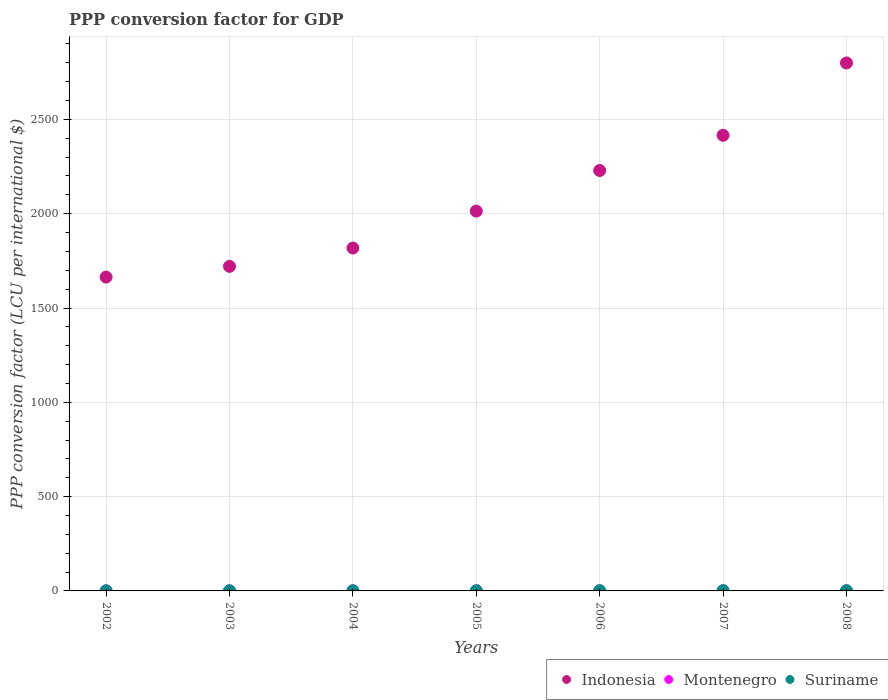Is the number of dotlines equal to the number of legend labels?
Your answer should be compact. Yes. What is the PPP conversion factor for GDP in Indonesia in 2002?
Your answer should be compact. 1663.89. Across all years, what is the maximum PPP conversion factor for GDP in Suriname?
Provide a short and direct response. 1.45. Across all years, what is the minimum PPP conversion factor for GDP in Suriname?
Give a very brief answer. 0.61. In which year was the PPP conversion factor for GDP in Indonesia minimum?
Give a very brief answer. 2002. What is the total PPP conversion factor for GDP in Montenegro in the graph?
Give a very brief answer. 2.39. What is the difference between the PPP conversion factor for GDP in Suriname in 2006 and that in 2008?
Your response must be concise. -0.22. What is the difference between the PPP conversion factor for GDP in Montenegro in 2004 and the PPP conversion factor for GDP in Suriname in 2005?
Keep it short and to the point. -0.55. What is the average PPP conversion factor for GDP in Indonesia per year?
Offer a terse response. 2094.35. In the year 2004, what is the difference between the PPP conversion factor for GDP in Montenegro and PPP conversion factor for GDP in Suriname?
Offer a very short reply. -0.46. In how many years, is the PPP conversion factor for GDP in Suriname greater than 1600 LCU?
Your answer should be compact. 0. What is the ratio of the PPP conversion factor for GDP in Suriname in 2005 to that in 2008?
Provide a short and direct response. 0.62. Is the PPP conversion factor for GDP in Indonesia in 2005 less than that in 2006?
Your response must be concise. Yes. What is the difference between the highest and the second highest PPP conversion factor for GDP in Montenegro?
Ensure brevity in your answer.  0.01. What is the difference between the highest and the lowest PPP conversion factor for GDP in Indonesia?
Offer a very short reply. 1135.31. Is the sum of the PPP conversion factor for GDP in Suriname in 2006 and 2007 greater than the maximum PPP conversion factor for GDP in Montenegro across all years?
Give a very brief answer. Yes. Is it the case that in every year, the sum of the PPP conversion factor for GDP in Suriname and PPP conversion factor for GDP in Montenegro  is greater than the PPP conversion factor for GDP in Indonesia?
Your answer should be compact. No. Does the PPP conversion factor for GDP in Suriname monotonically increase over the years?
Provide a short and direct response. Yes. Is the PPP conversion factor for GDP in Suriname strictly greater than the PPP conversion factor for GDP in Montenegro over the years?
Give a very brief answer. Yes. What is the difference between two consecutive major ticks on the Y-axis?
Ensure brevity in your answer.  500. Are the values on the major ticks of Y-axis written in scientific E-notation?
Provide a succinct answer. No. Does the graph contain any zero values?
Make the answer very short. No. Does the graph contain grids?
Keep it short and to the point. Yes. Where does the legend appear in the graph?
Offer a terse response. Bottom right. What is the title of the graph?
Offer a very short reply. PPP conversion factor for GDP. Does "Tuvalu" appear as one of the legend labels in the graph?
Offer a terse response. No. What is the label or title of the Y-axis?
Ensure brevity in your answer.  PPP conversion factor (LCU per international $). What is the PPP conversion factor (LCU per international $) of Indonesia in 2002?
Offer a terse response. 1663.89. What is the PPP conversion factor (LCU per international $) in Montenegro in 2002?
Your answer should be compact. 0.32. What is the PPP conversion factor (LCU per international $) of Suriname in 2002?
Keep it short and to the point. 0.61. What is the PPP conversion factor (LCU per international $) in Indonesia in 2003?
Give a very brief answer. 1720.88. What is the PPP conversion factor (LCU per international $) in Montenegro in 2003?
Give a very brief answer. 0.34. What is the PPP conversion factor (LCU per international $) in Suriname in 2003?
Give a very brief answer. 0.74. What is the PPP conversion factor (LCU per international $) in Indonesia in 2004?
Ensure brevity in your answer.  1818.04. What is the PPP conversion factor (LCU per international $) of Montenegro in 2004?
Make the answer very short. 0.35. What is the PPP conversion factor (LCU per international $) of Suriname in 2004?
Provide a succinct answer. 0.81. What is the PPP conversion factor (LCU per international $) of Indonesia in 2005?
Offer a very short reply. 2013.8. What is the PPP conversion factor (LCU per international $) of Montenegro in 2005?
Provide a succinct answer. 0.35. What is the PPP conversion factor (LCU per international $) in Suriname in 2005?
Ensure brevity in your answer.  0.9. What is the PPP conversion factor (LCU per international $) of Indonesia in 2006?
Offer a terse response. 2229.01. What is the PPP conversion factor (LCU per international $) of Montenegro in 2006?
Offer a terse response. 0.33. What is the PPP conversion factor (LCU per international $) of Suriname in 2006?
Provide a short and direct response. 1.24. What is the PPP conversion factor (LCU per international $) in Indonesia in 2007?
Ensure brevity in your answer.  2415.67. What is the PPP conversion factor (LCU per international $) in Montenegro in 2007?
Your answer should be very brief. 0.35. What is the PPP conversion factor (LCU per international $) in Suriname in 2007?
Provide a short and direct response. 1.28. What is the PPP conversion factor (LCU per international $) of Indonesia in 2008?
Offer a terse response. 2799.2. What is the PPP conversion factor (LCU per international $) of Montenegro in 2008?
Offer a terse response. 0.36. What is the PPP conversion factor (LCU per international $) of Suriname in 2008?
Keep it short and to the point. 1.45. Across all years, what is the maximum PPP conversion factor (LCU per international $) in Indonesia?
Your answer should be very brief. 2799.2. Across all years, what is the maximum PPP conversion factor (LCU per international $) of Montenegro?
Your response must be concise. 0.36. Across all years, what is the maximum PPP conversion factor (LCU per international $) of Suriname?
Your response must be concise. 1.45. Across all years, what is the minimum PPP conversion factor (LCU per international $) of Indonesia?
Your answer should be compact. 1663.89. Across all years, what is the minimum PPP conversion factor (LCU per international $) in Montenegro?
Offer a very short reply. 0.32. Across all years, what is the minimum PPP conversion factor (LCU per international $) in Suriname?
Provide a short and direct response. 0.61. What is the total PPP conversion factor (LCU per international $) of Indonesia in the graph?
Provide a short and direct response. 1.47e+04. What is the total PPP conversion factor (LCU per international $) in Montenegro in the graph?
Provide a short and direct response. 2.39. What is the total PPP conversion factor (LCU per international $) of Suriname in the graph?
Keep it short and to the point. 7.03. What is the difference between the PPP conversion factor (LCU per international $) in Indonesia in 2002 and that in 2003?
Offer a very short reply. -56.99. What is the difference between the PPP conversion factor (LCU per international $) in Montenegro in 2002 and that in 2003?
Provide a succinct answer. -0.02. What is the difference between the PPP conversion factor (LCU per international $) of Suriname in 2002 and that in 2003?
Offer a terse response. -0.13. What is the difference between the PPP conversion factor (LCU per international $) in Indonesia in 2002 and that in 2004?
Ensure brevity in your answer.  -154.15. What is the difference between the PPP conversion factor (LCU per international $) in Montenegro in 2002 and that in 2004?
Offer a very short reply. -0.03. What is the difference between the PPP conversion factor (LCU per international $) in Suriname in 2002 and that in 2004?
Your answer should be compact. -0.19. What is the difference between the PPP conversion factor (LCU per international $) of Indonesia in 2002 and that in 2005?
Give a very brief answer. -349.91. What is the difference between the PPP conversion factor (LCU per international $) of Montenegro in 2002 and that in 2005?
Give a very brief answer. -0.03. What is the difference between the PPP conversion factor (LCU per international $) of Suriname in 2002 and that in 2005?
Your answer should be compact. -0.29. What is the difference between the PPP conversion factor (LCU per international $) of Indonesia in 2002 and that in 2006?
Your response must be concise. -565.12. What is the difference between the PPP conversion factor (LCU per international $) in Montenegro in 2002 and that in 2006?
Provide a short and direct response. -0.01. What is the difference between the PPP conversion factor (LCU per international $) of Suriname in 2002 and that in 2006?
Your response must be concise. -0.63. What is the difference between the PPP conversion factor (LCU per international $) in Indonesia in 2002 and that in 2007?
Offer a terse response. -751.78. What is the difference between the PPP conversion factor (LCU per international $) in Montenegro in 2002 and that in 2007?
Make the answer very short. -0.03. What is the difference between the PPP conversion factor (LCU per international $) in Suriname in 2002 and that in 2007?
Ensure brevity in your answer.  -0.67. What is the difference between the PPP conversion factor (LCU per international $) of Indonesia in 2002 and that in 2008?
Your response must be concise. -1135.31. What is the difference between the PPP conversion factor (LCU per international $) of Montenegro in 2002 and that in 2008?
Ensure brevity in your answer.  -0.04. What is the difference between the PPP conversion factor (LCU per international $) of Suriname in 2002 and that in 2008?
Offer a terse response. -0.84. What is the difference between the PPP conversion factor (LCU per international $) in Indonesia in 2003 and that in 2004?
Your answer should be compact. -97.16. What is the difference between the PPP conversion factor (LCU per international $) in Montenegro in 2003 and that in 2004?
Provide a short and direct response. -0.01. What is the difference between the PPP conversion factor (LCU per international $) in Suriname in 2003 and that in 2004?
Your answer should be very brief. -0.07. What is the difference between the PPP conversion factor (LCU per international $) of Indonesia in 2003 and that in 2005?
Give a very brief answer. -292.92. What is the difference between the PPP conversion factor (LCU per international $) of Montenegro in 2003 and that in 2005?
Offer a very short reply. -0.01. What is the difference between the PPP conversion factor (LCU per international $) in Suriname in 2003 and that in 2005?
Give a very brief answer. -0.16. What is the difference between the PPP conversion factor (LCU per international $) of Indonesia in 2003 and that in 2006?
Your answer should be very brief. -508.13. What is the difference between the PPP conversion factor (LCU per international $) in Montenegro in 2003 and that in 2006?
Ensure brevity in your answer.  0.01. What is the difference between the PPP conversion factor (LCU per international $) in Suriname in 2003 and that in 2006?
Give a very brief answer. -0.5. What is the difference between the PPP conversion factor (LCU per international $) in Indonesia in 2003 and that in 2007?
Your response must be concise. -694.79. What is the difference between the PPP conversion factor (LCU per international $) of Montenegro in 2003 and that in 2007?
Provide a succinct answer. -0.01. What is the difference between the PPP conversion factor (LCU per international $) of Suriname in 2003 and that in 2007?
Your answer should be very brief. -0.55. What is the difference between the PPP conversion factor (LCU per international $) of Indonesia in 2003 and that in 2008?
Your answer should be very brief. -1078.32. What is the difference between the PPP conversion factor (LCU per international $) of Montenegro in 2003 and that in 2008?
Give a very brief answer. -0.02. What is the difference between the PPP conversion factor (LCU per international $) of Suriname in 2003 and that in 2008?
Make the answer very short. -0.72. What is the difference between the PPP conversion factor (LCU per international $) in Indonesia in 2004 and that in 2005?
Keep it short and to the point. -195.76. What is the difference between the PPP conversion factor (LCU per international $) of Montenegro in 2004 and that in 2005?
Offer a terse response. -0. What is the difference between the PPP conversion factor (LCU per international $) in Suriname in 2004 and that in 2005?
Make the answer very short. -0.1. What is the difference between the PPP conversion factor (LCU per international $) of Indonesia in 2004 and that in 2006?
Offer a very short reply. -410.97. What is the difference between the PPP conversion factor (LCU per international $) in Montenegro in 2004 and that in 2006?
Your response must be concise. 0.02. What is the difference between the PPP conversion factor (LCU per international $) of Suriname in 2004 and that in 2006?
Provide a short and direct response. -0.43. What is the difference between the PPP conversion factor (LCU per international $) of Indonesia in 2004 and that in 2007?
Offer a very short reply. -597.64. What is the difference between the PPP conversion factor (LCU per international $) of Montenegro in 2004 and that in 2007?
Keep it short and to the point. -0. What is the difference between the PPP conversion factor (LCU per international $) of Suriname in 2004 and that in 2007?
Provide a short and direct response. -0.48. What is the difference between the PPP conversion factor (LCU per international $) in Indonesia in 2004 and that in 2008?
Keep it short and to the point. -981.17. What is the difference between the PPP conversion factor (LCU per international $) in Montenegro in 2004 and that in 2008?
Your response must be concise. -0.01. What is the difference between the PPP conversion factor (LCU per international $) in Suriname in 2004 and that in 2008?
Your answer should be very brief. -0.65. What is the difference between the PPP conversion factor (LCU per international $) of Indonesia in 2005 and that in 2006?
Give a very brief answer. -215.21. What is the difference between the PPP conversion factor (LCU per international $) in Montenegro in 2005 and that in 2006?
Your answer should be compact. 0.02. What is the difference between the PPP conversion factor (LCU per international $) in Suriname in 2005 and that in 2006?
Your response must be concise. -0.34. What is the difference between the PPP conversion factor (LCU per international $) of Indonesia in 2005 and that in 2007?
Make the answer very short. -401.88. What is the difference between the PPP conversion factor (LCU per international $) of Montenegro in 2005 and that in 2007?
Your response must be concise. 0. What is the difference between the PPP conversion factor (LCU per international $) of Suriname in 2005 and that in 2007?
Your response must be concise. -0.38. What is the difference between the PPP conversion factor (LCU per international $) of Indonesia in 2005 and that in 2008?
Make the answer very short. -785.41. What is the difference between the PPP conversion factor (LCU per international $) in Montenegro in 2005 and that in 2008?
Keep it short and to the point. -0.01. What is the difference between the PPP conversion factor (LCU per international $) of Suriname in 2005 and that in 2008?
Offer a terse response. -0.55. What is the difference between the PPP conversion factor (LCU per international $) of Indonesia in 2006 and that in 2007?
Give a very brief answer. -186.67. What is the difference between the PPP conversion factor (LCU per international $) in Montenegro in 2006 and that in 2007?
Your response must be concise. -0.02. What is the difference between the PPP conversion factor (LCU per international $) of Suriname in 2006 and that in 2007?
Offer a very short reply. -0.05. What is the difference between the PPP conversion factor (LCU per international $) in Indonesia in 2006 and that in 2008?
Give a very brief answer. -570.19. What is the difference between the PPP conversion factor (LCU per international $) in Montenegro in 2006 and that in 2008?
Make the answer very short. -0.03. What is the difference between the PPP conversion factor (LCU per international $) in Suriname in 2006 and that in 2008?
Your answer should be very brief. -0.22. What is the difference between the PPP conversion factor (LCU per international $) in Indonesia in 2007 and that in 2008?
Your answer should be very brief. -383.53. What is the difference between the PPP conversion factor (LCU per international $) in Montenegro in 2007 and that in 2008?
Keep it short and to the point. -0.01. What is the difference between the PPP conversion factor (LCU per international $) of Suriname in 2007 and that in 2008?
Your answer should be very brief. -0.17. What is the difference between the PPP conversion factor (LCU per international $) in Indonesia in 2002 and the PPP conversion factor (LCU per international $) in Montenegro in 2003?
Your response must be concise. 1663.55. What is the difference between the PPP conversion factor (LCU per international $) of Indonesia in 2002 and the PPP conversion factor (LCU per international $) of Suriname in 2003?
Offer a terse response. 1663.15. What is the difference between the PPP conversion factor (LCU per international $) of Montenegro in 2002 and the PPP conversion factor (LCU per international $) of Suriname in 2003?
Provide a succinct answer. -0.42. What is the difference between the PPP conversion factor (LCU per international $) in Indonesia in 2002 and the PPP conversion factor (LCU per international $) in Montenegro in 2004?
Your answer should be compact. 1663.54. What is the difference between the PPP conversion factor (LCU per international $) in Indonesia in 2002 and the PPP conversion factor (LCU per international $) in Suriname in 2004?
Your answer should be very brief. 1663.08. What is the difference between the PPP conversion factor (LCU per international $) in Montenegro in 2002 and the PPP conversion factor (LCU per international $) in Suriname in 2004?
Your answer should be very brief. -0.49. What is the difference between the PPP conversion factor (LCU per international $) of Indonesia in 2002 and the PPP conversion factor (LCU per international $) of Montenegro in 2005?
Your response must be concise. 1663.54. What is the difference between the PPP conversion factor (LCU per international $) in Indonesia in 2002 and the PPP conversion factor (LCU per international $) in Suriname in 2005?
Your answer should be very brief. 1662.99. What is the difference between the PPP conversion factor (LCU per international $) in Montenegro in 2002 and the PPP conversion factor (LCU per international $) in Suriname in 2005?
Your response must be concise. -0.58. What is the difference between the PPP conversion factor (LCU per international $) in Indonesia in 2002 and the PPP conversion factor (LCU per international $) in Montenegro in 2006?
Provide a succinct answer. 1663.56. What is the difference between the PPP conversion factor (LCU per international $) in Indonesia in 2002 and the PPP conversion factor (LCU per international $) in Suriname in 2006?
Your answer should be very brief. 1662.65. What is the difference between the PPP conversion factor (LCU per international $) of Montenegro in 2002 and the PPP conversion factor (LCU per international $) of Suriname in 2006?
Provide a succinct answer. -0.92. What is the difference between the PPP conversion factor (LCU per international $) in Indonesia in 2002 and the PPP conversion factor (LCU per international $) in Montenegro in 2007?
Your answer should be compact. 1663.54. What is the difference between the PPP conversion factor (LCU per international $) of Indonesia in 2002 and the PPP conversion factor (LCU per international $) of Suriname in 2007?
Provide a short and direct response. 1662.61. What is the difference between the PPP conversion factor (LCU per international $) in Montenegro in 2002 and the PPP conversion factor (LCU per international $) in Suriname in 2007?
Offer a terse response. -0.97. What is the difference between the PPP conversion factor (LCU per international $) in Indonesia in 2002 and the PPP conversion factor (LCU per international $) in Montenegro in 2008?
Give a very brief answer. 1663.53. What is the difference between the PPP conversion factor (LCU per international $) of Indonesia in 2002 and the PPP conversion factor (LCU per international $) of Suriname in 2008?
Provide a succinct answer. 1662.43. What is the difference between the PPP conversion factor (LCU per international $) of Montenegro in 2002 and the PPP conversion factor (LCU per international $) of Suriname in 2008?
Make the answer very short. -1.14. What is the difference between the PPP conversion factor (LCU per international $) in Indonesia in 2003 and the PPP conversion factor (LCU per international $) in Montenegro in 2004?
Keep it short and to the point. 1720.53. What is the difference between the PPP conversion factor (LCU per international $) in Indonesia in 2003 and the PPP conversion factor (LCU per international $) in Suriname in 2004?
Offer a very short reply. 1720.07. What is the difference between the PPP conversion factor (LCU per international $) of Montenegro in 2003 and the PPP conversion factor (LCU per international $) of Suriname in 2004?
Offer a terse response. -0.47. What is the difference between the PPP conversion factor (LCU per international $) of Indonesia in 2003 and the PPP conversion factor (LCU per international $) of Montenegro in 2005?
Make the answer very short. 1720.53. What is the difference between the PPP conversion factor (LCU per international $) in Indonesia in 2003 and the PPP conversion factor (LCU per international $) in Suriname in 2005?
Provide a succinct answer. 1719.98. What is the difference between the PPP conversion factor (LCU per international $) of Montenegro in 2003 and the PPP conversion factor (LCU per international $) of Suriname in 2005?
Keep it short and to the point. -0.56. What is the difference between the PPP conversion factor (LCU per international $) in Indonesia in 2003 and the PPP conversion factor (LCU per international $) in Montenegro in 2006?
Make the answer very short. 1720.55. What is the difference between the PPP conversion factor (LCU per international $) in Indonesia in 2003 and the PPP conversion factor (LCU per international $) in Suriname in 2006?
Offer a very short reply. 1719.64. What is the difference between the PPP conversion factor (LCU per international $) in Montenegro in 2003 and the PPP conversion factor (LCU per international $) in Suriname in 2006?
Give a very brief answer. -0.9. What is the difference between the PPP conversion factor (LCU per international $) of Indonesia in 2003 and the PPP conversion factor (LCU per international $) of Montenegro in 2007?
Ensure brevity in your answer.  1720.53. What is the difference between the PPP conversion factor (LCU per international $) in Indonesia in 2003 and the PPP conversion factor (LCU per international $) in Suriname in 2007?
Give a very brief answer. 1719.6. What is the difference between the PPP conversion factor (LCU per international $) in Montenegro in 2003 and the PPP conversion factor (LCU per international $) in Suriname in 2007?
Ensure brevity in your answer.  -0.95. What is the difference between the PPP conversion factor (LCU per international $) in Indonesia in 2003 and the PPP conversion factor (LCU per international $) in Montenegro in 2008?
Ensure brevity in your answer.  1720.52. What is the difference between the PPP conversion factor (LCU per international $) of Indonesia in 2003 and the PPP conversion factor (LCU per international $) of Suriname in 2008?
Make the answer very short. 1719.42. What is the difference between the PPP conversion factor (LCU per international $) of Montenegro in 2003 and the PPP conversion factor (LCU per international $) of Suriname in 2008?
Keep it short and to the point. -1.12. What is the difference between the PPP conversion factor (LCU per international $) of Indonesia in 2004 and the PPP conversion factor (LCU per international $) of Montenegro in 2005?
Give a very brief answer. 1817.68. What is the difference between the PPP conversion factor (LCU per international $) in Indonesia in 2004 and the PPP conversion factor (LCU per international $) in Suriname in 2005?
Your answer should be compact. 1817.13. What is the difference between the PPP conversion factor (LCU per international $) of Montenegro in 2004 and the PPP conversion factor (LCU per international $) of Suriname in 2005?
Give a very brief answer. -0.55. What is the difference between the PPP conversion factor (LCU per international $) of Indonesia in 2004 and the PPP conversion factor (LCU per international $) of Montenegro in 2006?
Your answer should be very brief. 1817.7. What is the difference between the PPP conversion factor (LCU per international $) of Indonesia in 2004 and the PPP conversion factor (LCU per international $) of Suriname in 2006?
Provide a short and direct response. 1816.8. What is the difference between the PPP conversion factor (LCU per international $) of Montenegro in 2004 and the PPP conversion factor (LCU per international $) of Suriname in 2006?
Your answer should be compact. -0.89. What is the difference between the PPP conversion factor (LCU per international $) in Indonesia in 2004 and the PPP conversion factor (LCU per international $) in Montenegro in 2007?
Your answer should be compact. 1817.69. What is the difference between the PPP conversion factor (LCU per international $) in Indonesia in 2004 and the PPP conversion factor (LCU per international $) in Suriname in 2007?
Provide a succinct answer. 1816.75. What is the difference between the PPP conversion factor (LCU per international $) in Montenegro in 2004 and the PPP conversion factor (LCU per international $) in Suriname in 2007?
Make the answer very short. -0.94. What is the difference between the PPP conversion factor (LCU per international $) in Indonesia in 2004 and the PPP conversion factor (LCU per international $) in Montenegro in 2008?
Provide a short and direct response. 1817.68. What is the difference between the PPP conversion factor (LCU per international $) of Indonesia in 2004 and the PPP conversion factor (LCU per international $) of Suriname in 2008?
Give a very brief answer. 1816.58. What is the difference between the PPP conversion factor (LCU per international $) of Montenegro in 2004 and the PPP conversion factor (LCU per international $) of Suriname in 2008?
Keep it short and to the point. -1.11. What is the difference between the PPP conversion factor (LCU per international $) in Indonesia in 2005 and the PPP conversion factor (LCU per international $) in Montenegro in 2006?
Your answer should be very brief. 2013.46. What is the difference between the PPP conversion factor (LCU per international $) of Indonesia in 2005 and the PPP conversion factor (LCU per international $) of Suriname in 2006?
Provide a short and direct response. 2012.56. What is the difference between the PPP conversion factor (LCU per international $) in Montenegro in 2005 and the PPP conversion factor (LCU per international $) in Suriname in 2006?
Offer a very short reply. -0.89. What is the difference between the PPP conversion factor (LCU per international $) in Indonesia in 2005 and the PPP conversion factor (LCU per international $) in Montenegro in 2007?
Offer a very short reply. 2013.45. What is the difference between the PPP conversion factor (LCU per international $) in Indonesia in 2005 and the PPP conversion factor (LCU per international $) in Suriname in 2007?
Offer a very short reply. 2012.51. What is the difference between the PPP conversion factor (LCU per international $) of Montenegro in 2005 and the PPP conversion factor (LCU per international $) of Suriname in 2007?
Offer a very short reply. -0.93. What is the difference between the PPP conversion factor (LCU per international $) in Indonesia in 2005 and the PPP conversion factor (LCU per international $) in Montenegro in 2008?
Offer a terse response. 2013.44. What is the difference between the PPP conversion factor (LCU per international $) in Indonesia in 2005 and the PPP conversion factor (LCU per international $) in Suriname in 2008?
Your answer should be very brief. 2012.34. What is the difference between the PPP conversion factor (LCU per international $) in Montenegro in 2005 and the PPP conversion factor (LCU per international $) in Suriname in 2008?
Make the answer very short. -1.1. What is the difference between the PPP conversion factor (LCU per international $) in Indonesia in 2006 and the PPP conversion factor (LCU per international $) in Montenegro in 2007?
Your answer should be compact. 2228.66. What is the difference between the PPP conversion factor (LCU per international $) of Indonesia in 2006 and the PPP conversion factor (LCU per international $) of Suriname in 2007?
Your answer should be compact. 2227.72. What is the difference between the PPP conversion factor (LCU per international $) of Montenegro in 2006 and the PPP conversion factor (LCU per international $) of Suriname in 2007?
Offer a very short reply. -0.95. What is the difference between the PPP conversion factor (LCU per international $) in Indonesia in 2006 and the PPP conversion factor (LCU per international $) in Montenegro in 2008?
Make the answer very short. 2228.65. What is the difference between the PPP conversion factor (LCU per international $) of Indonesia in 2006 and the PPP conversion factor (LCU per international $) of Suriname in 2008?
Offer a very short reply. 2227.55. What is the difference between the PPP conversion factor (LCU per international $) in Montenegro in 2006 and the PPP conversion factor (LCU per international $) in Suriname in 2008?
Your answer should be compact. -1.12. What is the difference between the PPP conversion factor (LCU per international $) of Indonesia in 2007 and the PPP conversion factor (LCU per international $) of Montenegro in 2008?
Offer a terse response. 2415.31. What is the difference between the PPP conversion factor (LCU per international $) of Indonesia in 2007 and the PPP conversion factor (LCU per international $) of Suriname in 2008?
Your answer should be very brief. 2414.22. What is the difference between the PPP conversion factor (LCU per international $) in Montenegro in 2007 and the PPP conversion factor (LCU per international $) in Suriname in 2008?
Make the answer very short. -1.11. What is the average PPP conversion factor (LCU per international $) of Indonesia per year?
Provide a succinct answer. 2094.35. What is the average PPP conversion factor (LCU per international $) in Montenegro per year?
Ensure brevity in your answer.  0.34. In the year 2002, what is the difference between the PPP conversion factor (LCU per international $) of Indonesia and PPP conversion factor (LCU per international $) of Montenegro?
Your answer should be very brief. 1663.57. In the year 2002, what is the difference between the PPP conversion factor (LCU per international $) in Indonesia and PPP conversion factor (LCU per international $) in Suriname?
Provide a succinct answer. 1663.28. In the year 2002, what is the difference between the PPP conversion factor (LCU per international $) of Montenegro and PPP conversion factor (LCU per international $) of Suriname?
Keep it short and to the point. -0.29. In the year 2003, what is the difference between the PPP conversion factor (LCU per international $) of Indonesia and PPP conversion factor (LCU per international $) of Montenegro?
Keep it short and to the point. 1720.54. In the year 2003, what is the difference between the PPP conversion factor (LCU per international $) in Indonesia and PPP conversion factor (LCU per international $) in Suriname?
Your answer should be compact. 1720.14. In the year 2003, what is the difference between the PPP conversion factor (LCU per international $) in Montenegro and PPP conversion factor (LCU per international $) in Suriname?
Provide a succinct answer. -0.4. In the year 2004, what is the difference between the PPP conversion factor (LCU per international $) in Indonesia and PPP conversion factor (LCU per international $) in Montenegro?
Ensure brevity in your answer.  1817.69. In the year 2004, what is the difference between the PPP conversion factor (LCU per international $) in Indonesia and PPP conversion factor (LCU per international $) in Suriname?
Keep it short and to the point. 1817.23. In the year 2004, what is the difference between the PPP conversion factor (LCU per international $) of Montenegro and PPP conversion factor (LCU per international $) of Suriname?
Offer a very short reply. -0.46. In the year 2005, what is the difference between the PPP conversion factor (LCU per international $) of Indonesia and PPP conversion factor (LCU per international $) of Montenegro?
Keep it short and to the point. 2013.44. In the year 2005, what is the difference between the PPP conversion factor (LCU per international $) in Indonesia and PPP conversion factor (LCU per international $) in Suriname?
Your answer should be very brief. 2012.89. In the year 2005, what is the difference between the PPP conversion factor (LCU per international $) of Montenegro and PPP conversion factor (LCU per international $) of Suriname?
Provide a short and direct response. -0.55. In the year 2006, what is the difference between the PPP conversion factor (LCU per international $) of Indonesia and PPP conversion factor (LCU per international $) of Montenegro?
Provide a succinct answer. 2228.68. In the year 2006, what is the difference between the PPP conversion factor (LCU per international $) in Indonesia and PPP conversion factor (LCU per international $) in Suriname?
Keep it short and to the point. 2227.77. In the year 2006, what is the difference between the PPP conversion factor (LCU per international $) in Montenegro and PPP conversion factor (LCU per international $) in Suriname?
Your answer should be very brief. -0.91. In the year 2007, what is the difference between the PPP conversion factor (LCU per international $) of Indonesia and PPP conversion factor (LCU per international $) of Montenegro?
Your answer should be compact. 2415.32. In the year 2007, what is the difference between the PPP conversion factor (LCU per international $) in Indonesia and PPP conversion factor (LCU per international $) in Suriname?
Offer a terse response. 2414.39. In the year 2007, what is the difference between the PPP conversion factor (LCU per international $) in Montenegro and PPP conversion factor (LCU per international $) in Suriname?
Keep it short and to the point. -0.94. In the year 2008, what is the difference between the PPP conversion factor (LCU per international $) in Indonesia and PPP conversion factor (LCU per international $) in Montenegro?
Offer a very short reply. 2798.84. In the year 2008, what is the difference between the PPP conversion factor (LCU per international $) of Indonesia and PPP conversion factor (LCU per international $) of Suriname?
Provide a succinct answer. 2797.75. In the year 2008, what is the difference between the PPP conversion factor (LCU per international $) in Montenegro and PPP conversion factor (LCU per international $) in Suriname?
Make the answer very short. -1.1. What is the ratio of the PPP conversion factor (LCU per international $) of Indonesia in 2002 to that in 2003?
Make the answer very short. 0.97. What is the ratio of the PPP conversion factor (LCU per international $) of Montenegro in 2002 to that in 2003?
Your response must be concise. 0.94. What is the ratio of the PPP conversion factor (LCU per international $) of Suriname in 2002 to that in 2003?
Provide a succinct answer. 0.83. What is the ratio of the PPP conversion factor (LCU per international $) of Indonesia in 2002 to that in 2004?
Your answer should be very brief. 0.92. What is the ratio of the PPP conversion factor (LCU per international $) of Montenegro in 2002 to that in 2004?
Offer a terse response. 0.91. What is the ratio of the PPP conversion factor (LCU per international $) of Suriname in 2002 to that in 2004?
Provide a short and direct response. 0.76. What is the ratio of the PPP conversion factor (LCU per international $) in Indonesia in 2002 to that in 2005?
Ensure brevity in your answer.  0.83. What is the ratio of the PPP conversion factor (LCU per international $) of Montenegro in 2002 to that in 2005?
Ensure brevity in your answer.  0.9. What is the ratio of the PPP conversion factor (LCU per international $) in Suriname in 2002 to that in 2005?
Your answer should be very brief. 0.68. What is the ratio of the PPP conversion factor (LCU per international $) in Indonesia in 2002 to that in 2006?
Make the answer very short. 0.75. What is the ratio of the PPP conversion factor (LCU per international $) of Montenegro in 2002 to that in 2006?
Your answer should be compact. 0.96. What is the ratio of the PPP conversion factor (LCU per international $) of Suriname in 2002 to that in 2006?
Give a very brief answer. 0.49. What is the ratio of the PPP conversion factor (LCU per international $) in Indonesia in 2002 to that in 2007?
Your answer should be compact. 0.69. What is the ratio of the PPP conversion factor (LCU per international $) in Montenegro in 2002 to that in 2007?
Make the answer very short. 0.91. What is the ratio of the PPP conversion factor (LCU per international $) in Suriname in 2002 to that in 2007?
Provide a succinct answer. 0.48. What is the ratio of the PPP conversion factor (LCU per international $) of Indonesia in 2002 to that in 2008?
Your answer should be very brief. 0.59. What is the ratio of the PPP conversion factor (LCU per international $) in Montenegro in 2002 to that in 2008?
Your answer should be compact. 0.88. What is the ratio of the PPP conversion factor (LCU per international $) of Suriname in 2002 to that in 2008?
Give a very brief answer. 0.42. What is the ratio of the PPP conversion factor (LCU per international $) in Indonesia in 2003 to that in 2004?
Make the answer very short. 0.95. What is the ratio of the PPP conversion factor (LCU per international $) in Montenegro in 2003 to that in 2004?
Provide a short and direct response. 0.97. What is the ratio of the PPP conversion factor (LCU per international $) in Suriname in 2003 to that in 2004?
Your answer should be compact. 0.91. What is the ratio of the PPP conversion factor (LCU per international $) of Indonesia in 2003 to that in 2005?
Provide a short and direct response. 0.85. What is the ratio of the PPP conversion factor (LCU per international $) in Montenegro in 2003 to that in 2005?
Offer a terse response. 0.96. What is the ratio of the PPP conversion factor (LCU per international $) in Suriname in 2003 to that in 2005?
Offer a terse response. 0.82. What is the ratio of the PPP conversion factor (LCU per international $) in Indonesia in 2003 to that in 2006?
Keep it short and to the point. 0.77. What is the ratio of the PPP conversion factor (LCU per international $) of Montenegro in 2003 to that in 2006?
Provide a short and direct response. 1.02. What is the ratio of the PPP conversion factor (LCU per international $) in Suriname in 2003 to that in 2006?
Your answer should be compact. 0.6. What is the ratio of the PPP conversion factor (LCU per international $) in Indonesia in 2003 to that in 2007?
Provide a short and direct response. 0.71. What is the ratio of the PPP conversion factor (LCU per international $) in Montenegro in 2003 to that in 2007?
Give a very brief answer. 0.97. What is the ratio of the PPP conversion factor (LCU per international $) of Suriname in 2003 to that in 2007?
Provide a short and direct response. 0.57. What is the ratio of the PPP conversion factor (LCU per international $) in Indonesia in 2003 to that in 2008?
Ensure brevity in your answer.  0.61. What is the ratio of the PPP conversion factor (LCU per international $) of Montenegro in 2003 to that in 2008?
Give a very brief answer. 0.94. What is the ratio of the PPP conversion factor (LCU per international $) of Suriname in 2003 to that in 2008?
Keep it short and to the point. 0.51. What is the ratio of the PPP conversion factor (LCU per international $) in Indonesia in 2004 to that in 2005?
Provide a succinct answer. 0.9. What is the ratio of the PPP conversion factor (LCU per international $) in Montenegro in 2004 to that in 2005?
Offer a terse response. 0.99. What is the ratio of the PPP conversion factor (LCU per international $) of Suriname in 2004 to that in 2005?
Make the answer very short. 0.89. What is the ratio of the PPP conversion factor (LCU per international $) in Indonesia in 2004 to that in 2006?
Keep it short and to the point. 0.82. What is the ratio of the PPP conversion factor (LCU per international $) of Montenegro in 2004 to that in 2006?
Offer a terse response. 1.05. What is the ratio of the PPP conversion factor (LCU per international $) of Suriname in 2004 to that in 2006?
Give a very brief answer. 0.65. What is the ratio of the PPP conversion factor (LCU per international $) in Indonesia in 2004 to that in 2007?
Make the answer very short. 0.75. What is the ratio of the PPP conversion factor (LCU per international $) in Montenegro in 2004 to that in 2007?
Ensure brevity in your answer.  1. What is the ratio of the PPP conversion factor (LCU per international $) of Suriname in 2004 to that in 2007?
Your response must be concise. 0.63. What is the ratio of the PPP conversion factor (LCU per international $) of Indonesia in 2004 to that in 2008?
Keep it short and to the point. 0.65. What is the ratio of the PPP conversion factor (LCU per international $) in Suriname in 2004 to that in 2008?
Your response must be concise. 0.55. What is the ratio of the PPP conversion factor (LCU per international $) in Indonesia in 2005 to that in 2006?
Provide a short and direct response. 0.9. What is the ratio of the PPP conversion factor (LCU per international $) in Montenegro in 2005 to that in 2006?
Give a very brief answer. 1.06. What is the ratio of the PPP conversion factor (LCU per international $) of Suriname in 2005 to that in 2006?
Your answer should be compact. 0.73. What is the ratio of the PPP conversion factor (LCU per international $) in Indonesia in 2005 to that in 2007?
Your response must be concise. 0.83. What is the ratio of the PPP conversion factor (LCU per international $) in Montenegro in 2005 to that in 2007?
Offer a very short reply. 1.01. What is the ratio of the PPP conversion factor (LCU per international $) of Suriname in 2005 to that in 2007?
Provide a short and direct response. 0.7. What is the ratio of the PPP conversion factor (LCU per international $) of Indonesia in 2005 to that in 2008?
Offer a terse response. 0.72. What is the ratio of the PPP conversion factor (LCU per international $) of Montenegro in 2005 to that in 2008?
Keep it short and to the point. 0.98. What is the ratio of the PPP conversion factor (LCU per international $) of Suriname in 2005 to that in 2008?
Offer a very short reply. 0.62. What is the ratio of the PPP conversion factor (LCU per international $) of Indonesia in 2006 to that in 2007?
Ensure brevity in your answer.  0.92. What is the ratio of the PPP conversion factor (LCU per international $) in Montenegro in 2006 to that in 2007?
Ensure brevity in your answer.  0.95. What is the ratio of the PPP conversion factor (LCU per international $) of Suriname in 2006 to that in 2007?
Provide a succinct answer. 0.96. What is the ratio of the PPP conversion factor (LCU per international $) of Indonesia in 2006 to that in 2008?
Your answer should be compact. 0.8. What is the ratio of the PPP conversion factor (LCU per international $) of Montenegro in 2006 to that in 2008?
Your answer should be very brief. 0.92. What is the ratio of the PPP conversion factor (LCU per international $) in Suriname in 2006 to that in 2008?
Ensure brevity in your answer.  0.85. What is the ratio of the PPP conversion factor (LCU per international $) in Indonesia in 2007 to that in 2008?
Ensure brevity in your answer.  0.86. What is the ratio of the PPP conversion factor (LCU per international $) of Montenegro in 2007 to that in 2008?
Give a very brief answer. 0.97. What is the ratio of the PPP conversion factor (LCU per international $) in Suriname in 2007 to that in 2008?
Give a very brief answer. 0.88. What is the difference between the highest and the second highest PPP conversion factor (LCU per international $) of Indonesia?
Provide a succinct answer. 383.53. What is the difference between the highest and the second highest PPP conversion factor (LCU per international $) of Montenegro?
Provide a succinct answer. 0.01. What is the difference between the highest and the second highest PPP conversion factor (LCU per international $) in Suriname?
Ensure brevity in your answer.  0.17. What is the difference between the highest and the lowest PPP conversion factor (LCU per international $) in Indonesia?
Make the answer very short. 1135.31. What is the difference between the highest and the lowest PPP conversion factor (LCU per international $) in Montenegro?
Provide a succinct answer. 0.04. What is the difference between the highest and the lowest PPP conversion factor (LCU per international $) of Suriname?
Your answer should be compact. 0.84. 